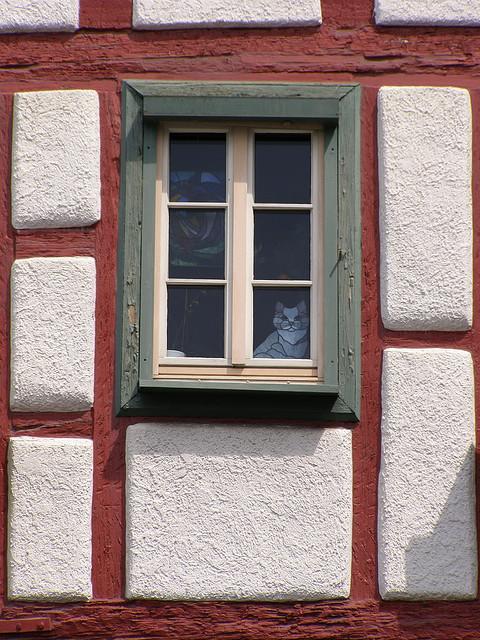What is seen in the pic?
Write a very short answer. Window. What is happening to the green paint on the window?
Answer briefly. Peeling. What color is the window frame?
Keep it brief. Green. 